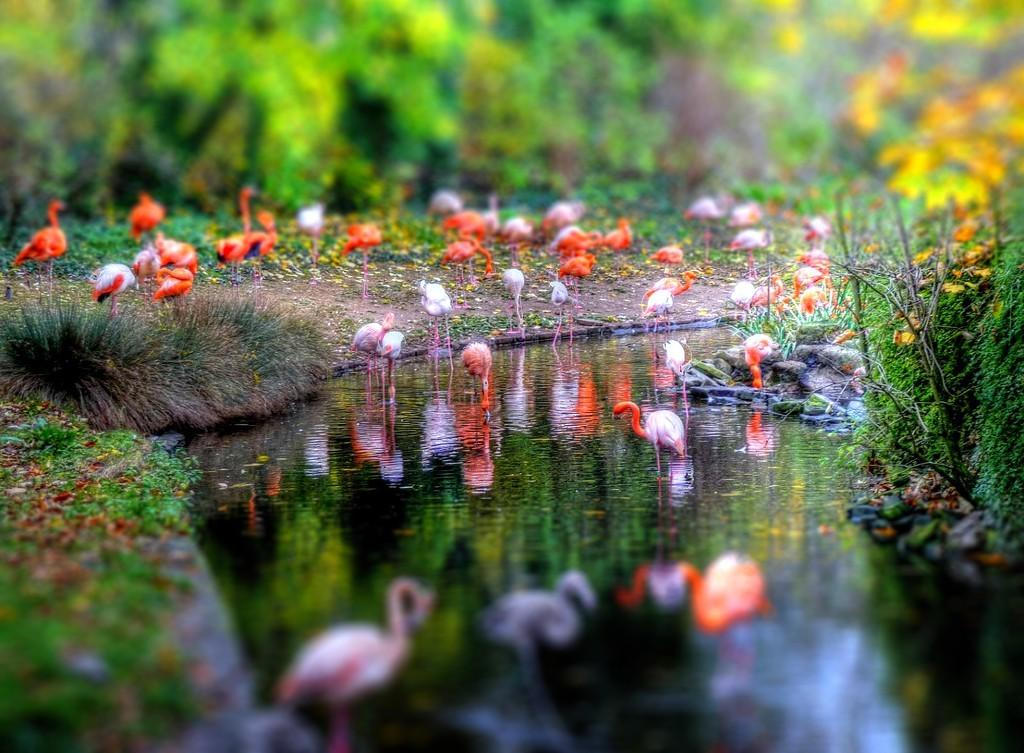What is located at the bottom of the image? There is a pond at the bottom of the image. What type of vegetation can be seen on both sides of the image? There is grass on both the right and left sides of the image. What other types of plants are visible in the image? There are plants in the image. What can be seen in the background of the image? There are birds, trees, and flowers visible in the background. How does the wealth of the birds in the image affect their ability to turn? There is no indication of the birds' wealth in the image, and therefore it cannot be determined how it might affect their ability to turn. 